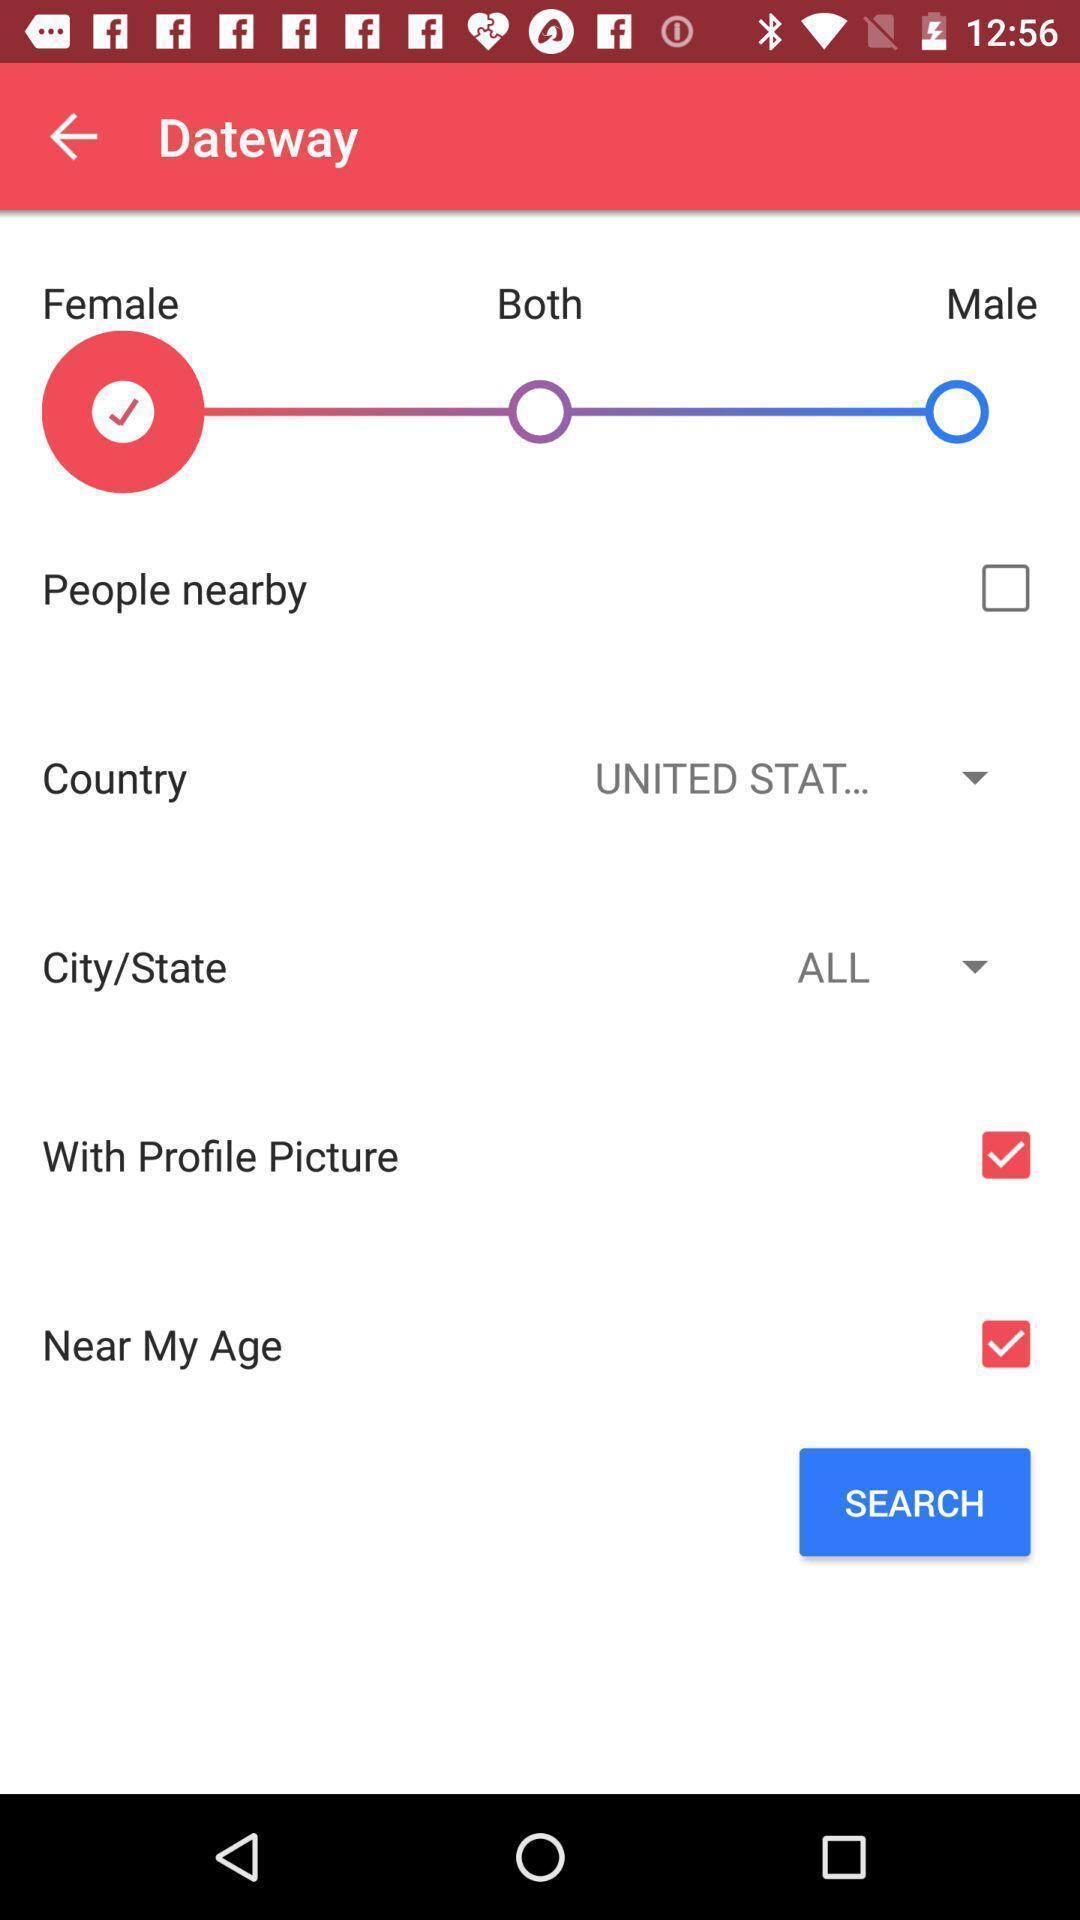Explain what's happening in this screen capture. Page showing different options. 